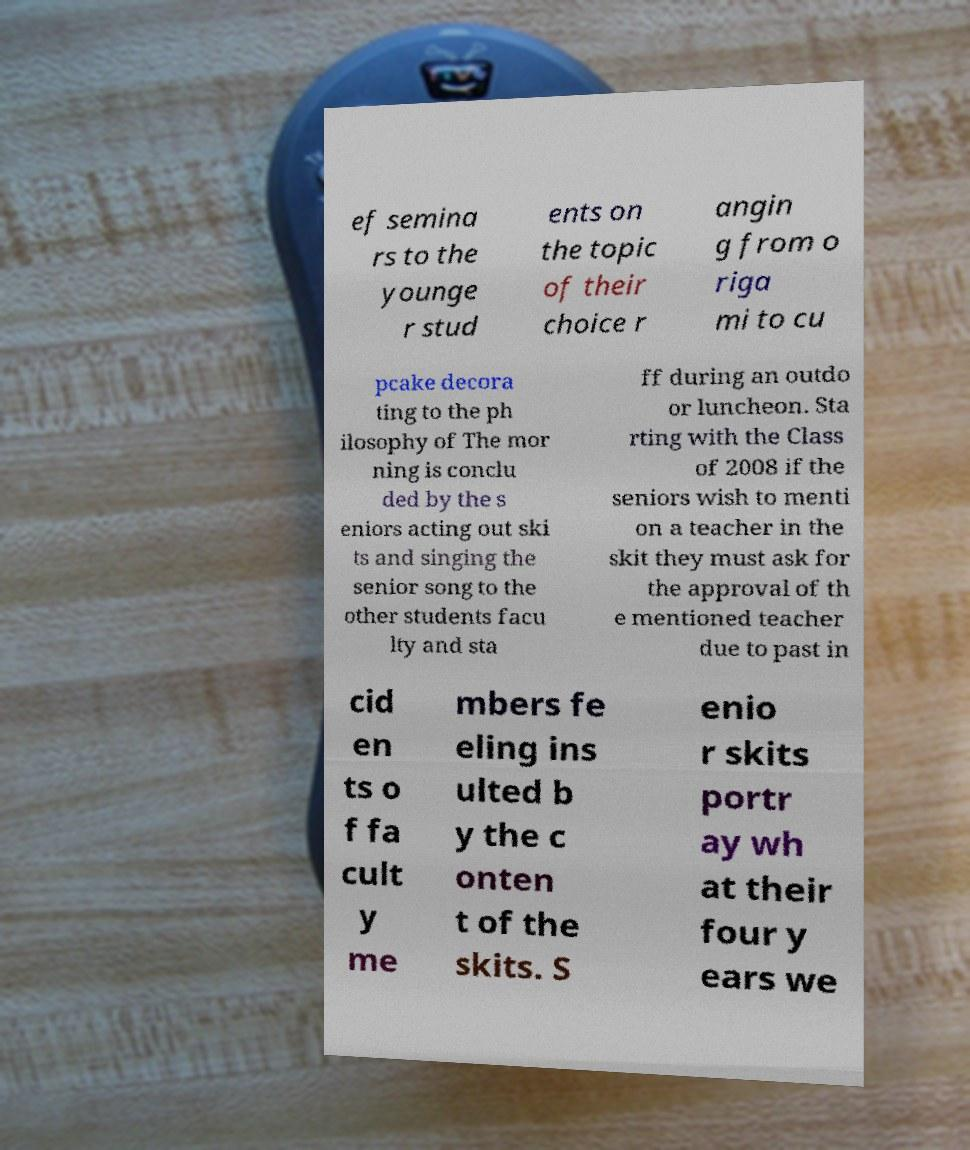Can you accurately transcribe the text from the provided image for me? ef semina rs to the younge r stud ents on the topic of their choice r angin g from o riga mi to cu pcake decora ting to the ph ilosophy of The mor ning is conclu ded by the s eniors acting out ski ts and singing the senior song to the other students facu lty and sta ff during an outdo or luncheon. Sta rting with the Class of 2008 if the seniors wish to menti on a teacher in the skit they must ask for the approval of th e mentioned teacher due to past in cid en ts o f fa cult y me mbers fe eling ins ulted b y the c onten t of the skits. S enio r skits portr ay wh at their four y ears we 